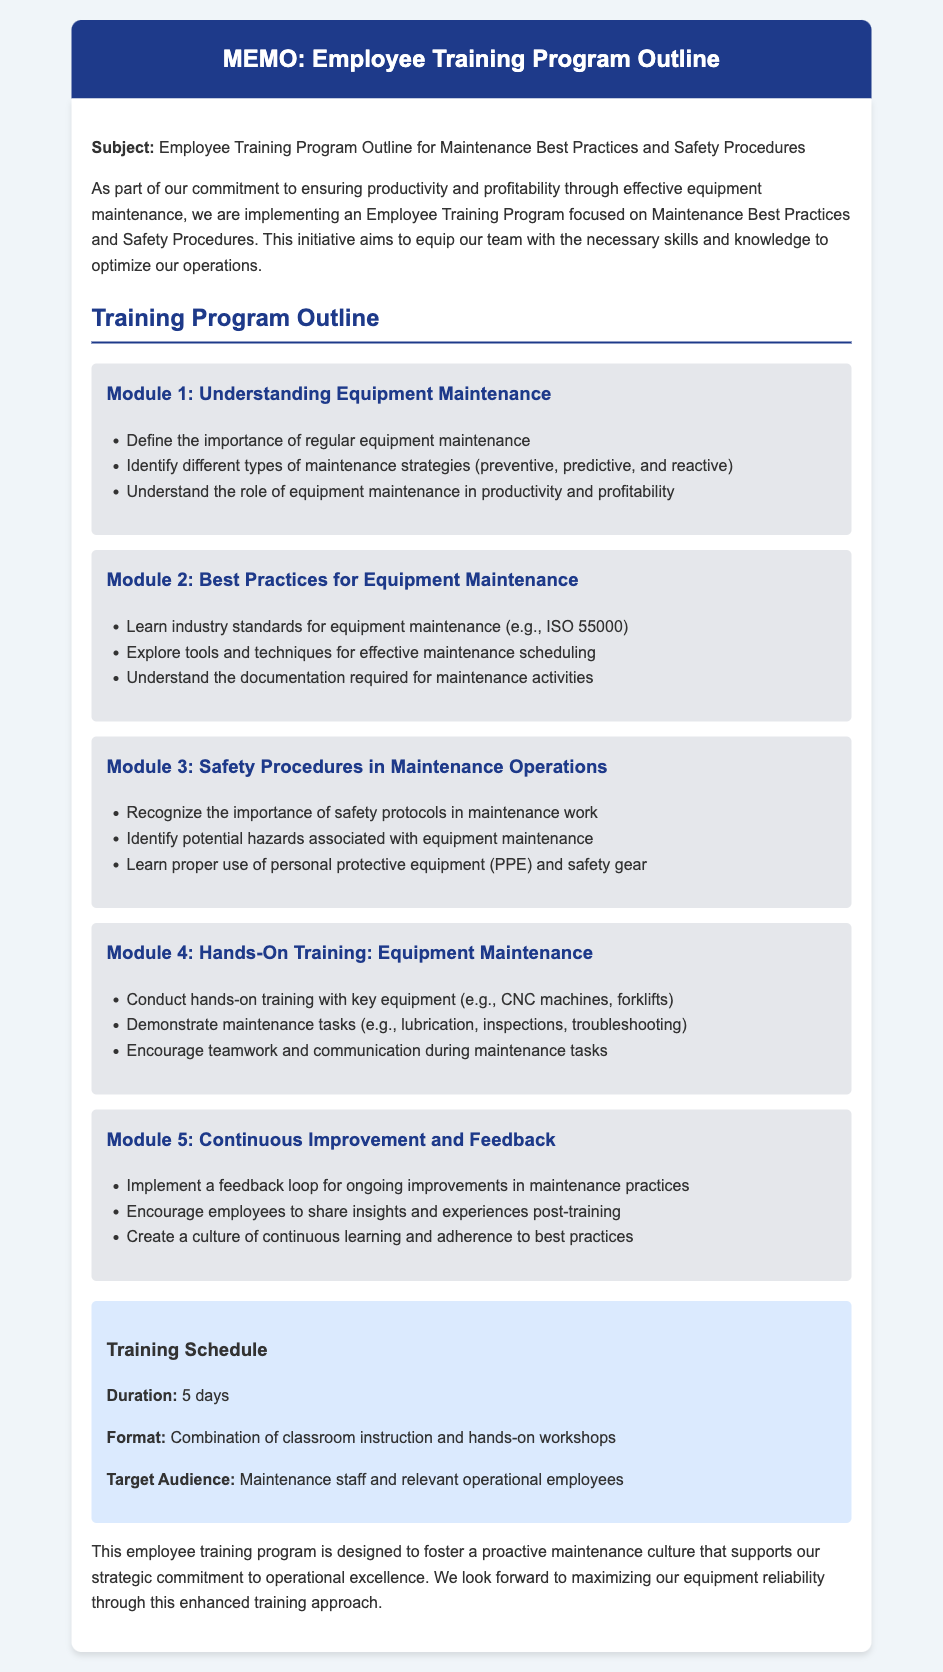What is the subject of the memo? The subject of the memo is stated in the first paragraph, focusing on an Employee Training Program Outline for Maintenance Best Practices and Safety Procedures.
Answer: Employee Training Program Outline for Maintenance Best Practices and Safety Procedures How many modules are in the training program? The document lists five distinct modules, each addressing different aspects of equipment maintenance and safety procedures.
Answer: 5 What is covered in Module 3? The contents of Module 3 discuss safety procedures, including the importance of safety protocols and identification of hazards in maintenance work.
Answer: Safety Procedures in Maintenance Operations What is the duration of the training program? The document specifies that the duration of the training program is five days.
Answer: 5 days Who is the target audience for the training? The memo specifies that the target audience includes maintenance staff and relevant operational employees.
Answer: Maintenance staff and relevant operational employees In Module 2, which standard is mentioned? The text in Module 2 refers to ISO 55000 as an industry standard for equipment maintenance.
Answer: ISO 55000 What type of training format is used? The memo mentions a combination of classroom instruction and hands-on workshops as the format for the training.
Answer: Combination of classroom instruction and hands-on workshops What is encouraged in Module 5? Module 5 emphasizes the implementation of a feedback loop for ongoing improvements and encourages insights from employees post-training.
Answer: Feedback loop for ongoing improvements What is the purpose of the training program? The purpose is to foster a proactive maintenance culture that supports the strategic commitment to operational excellence.
Answer: Foster a proactive maintenance culture 